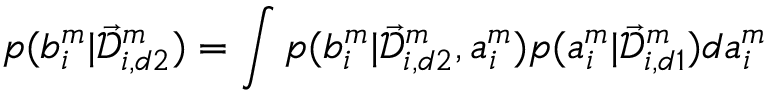Convert formula to latex. <formula><loc_0><loc_0><loc_500><loc_500>p ( b _ { i } ^ { m } | \mathcal { \vec { D } } _ { i , d 2 } ^ { m } ) = \int p ( b _ { i } ^ { m } | \mathcal { \vec { D } } _ { i , d 2 } ^ { m } , a _ { i } ^ { m } ) p ( a _ { i } ^ { m } | \mathcal { \vec { D } } _ { i , d 1 } ^ { m } ) d a _ { i } ^ { m }</formula> 